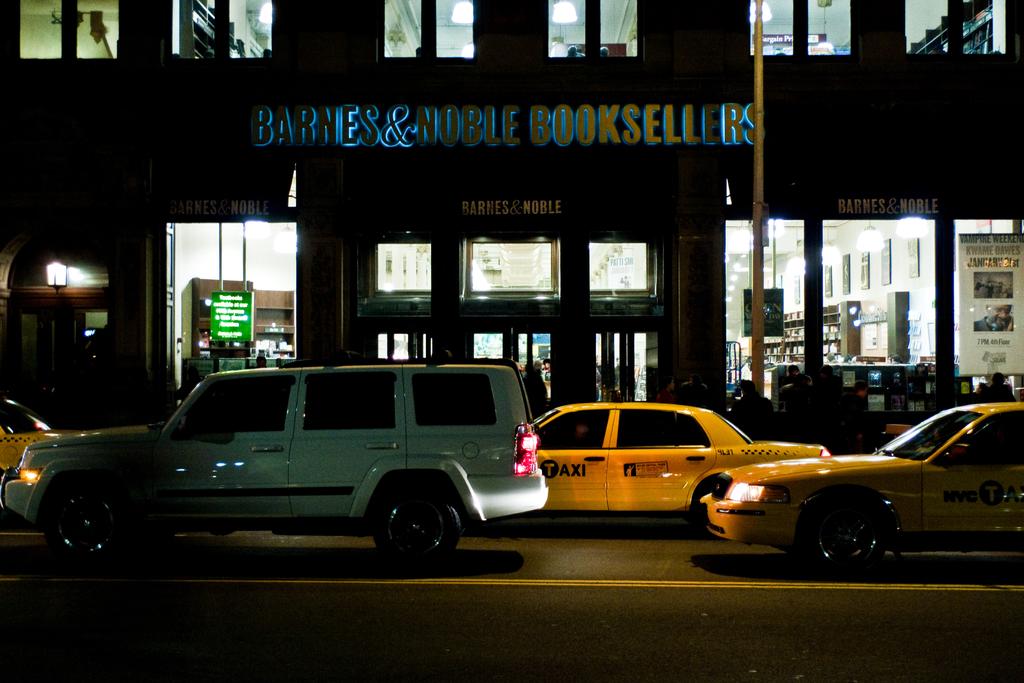What does this store sell?
Offer a terse response. Books. What is the name of the store?
Your answer should be very brief. Barnes & noble booksellers. 